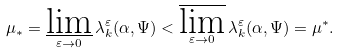Convert formula to latex. <formula><loc_0><loc_0><loc_500><loc_500>\mu _ { * } = \varliminf _ { \varepsilon \to 0 } \lambda _ { k } ^ { \varepsilon } ( \alpha , \Psi ) < \varlimsup _ { \varepsilon \to 0 } \lambda _ { k } ^ { \varepsilon } ( \alpha , \Psi ) = \mu ^ { * } .</formula> 